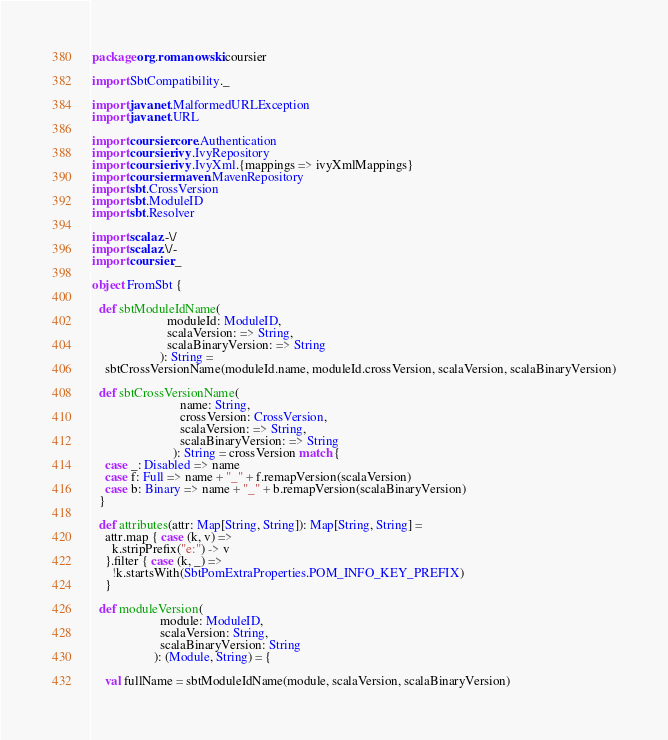Convert code to text. <code><loc_0><loc_0><loc_500><loc_500><_Scala_>package org.romanowski.coursier

import SbtCompatibility._

import java.net.MalformedURLException
import java.net.URL

import coursier.core.Authentication
import coursier.ivy.IvyRepository
import coursier.ivy.IvyXml.{mappings => ivyXmlMappings}
import coursier.maven.MavenRepository
import sbt.CrossVersion
import sbt.ModuleID
import sbt.Resolver

import scalaz.-\/
import scalaz.\/-
import coursier._

object FromSbt {

  def sbtModuleIdName(
                       moduleId: ModuleID,
                       scalaVersion: => String,
                       scalaBinaryVersion: => String
                     ): String =
    sbtCrossVersionName(moduleId.name, moduleId.crossVersion, scalaVersion, scalaBinaryVersion)

  def sbtCrossVersionName(
                           name: String,
                           crossVersion: CrossVersion,
                           scalaVersion: => String,
                           scalaBinaryVersion: => String
                         ): String = crossVersion match {
    case _: Disabled => name
    case f: Full => name + "_" + f.remapVersion(scalaVersion)
    case b: Binary => name + "_" + b.remapVersion(scalaBinaryVersion)
  }

  def attributes(attr: Map[String, String]): Map[String, String] =
    attr.map { case (k, v) =>
      k.stripPrefix("e:") -> v
    }.filter { case (k, _) =>
      !k.startsWith(SbtPomExtraProperties.POM_INFO_KEY_PREFIX)
    }

  def moduleVersion(
                     module: ModuleID,
                     scalaVersion: String,
                     scalaBinaryVersion: String
                   ): (Module, String) = {

    val fullName = sbtModuleIdName(module, scalaVersion, scalaBinaryVersion)
</code> 